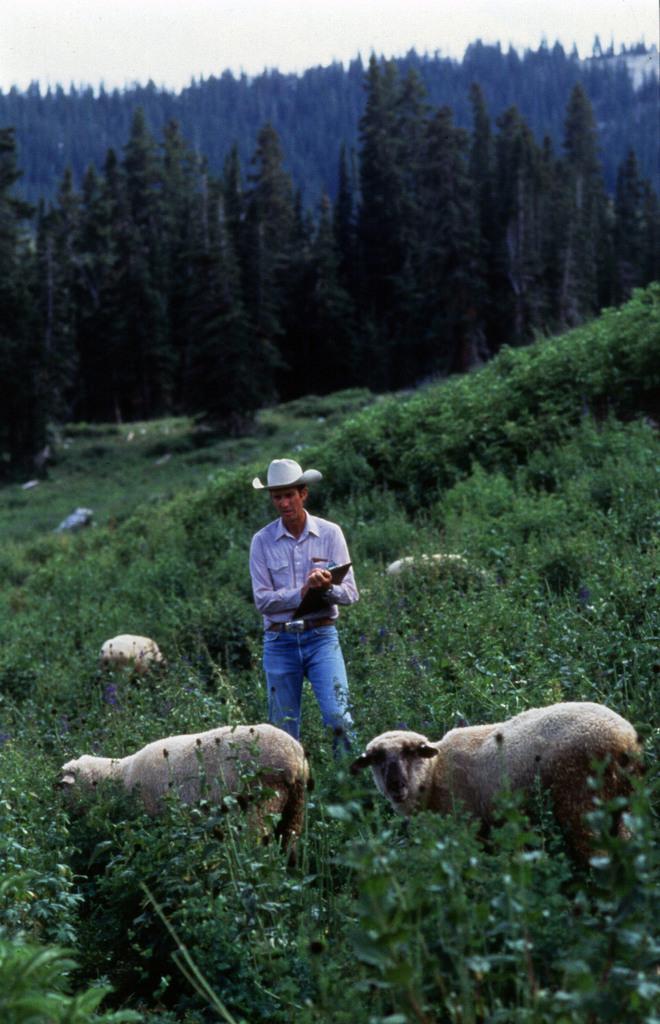Could you give a brief overview of what you see in this image? In this image we can see a man standing holding a pad. We can also see a group of herd, some plants, a group of trees and the sky which looks cloudy. 